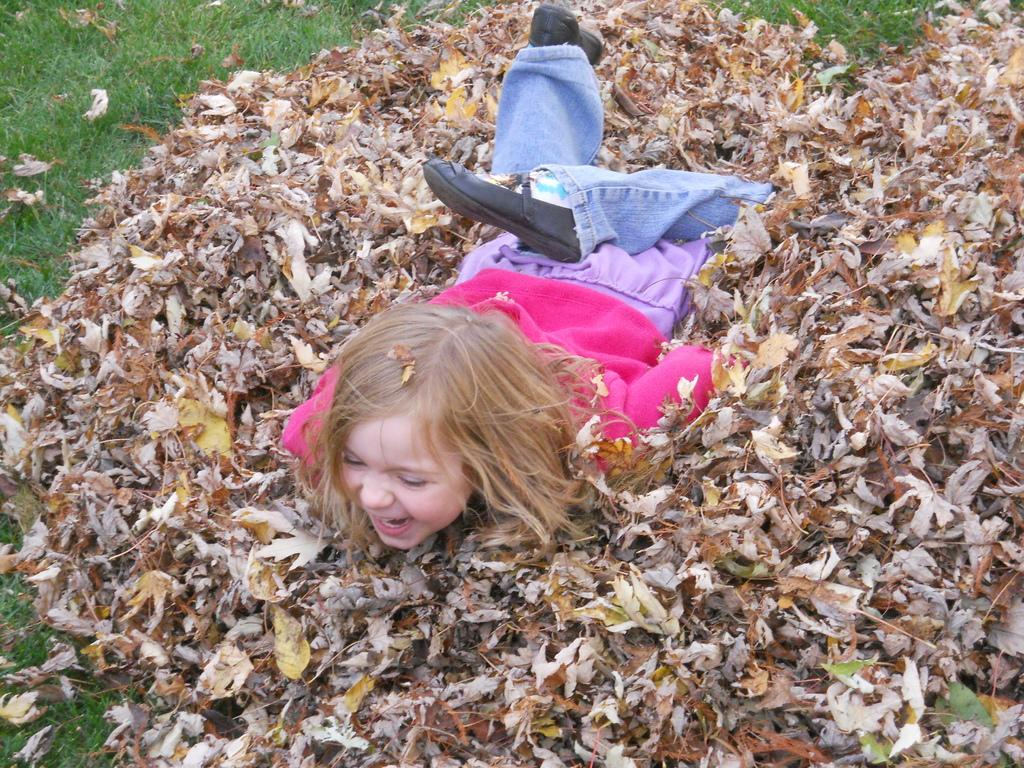What is the main subject of the image? The main subject of the image is a kid. What is the kid wearing? The kid is wearing a pink sweater, blue jeans, and black shoes. What is the kid doing in the image? The kid is sleeping on dry leaves. Where are the dry leaves located? The dry leaves are on the ground. What type of vegetation can be seen in the image? There is grass in the image. What type of street can be seen in the image? There is no street present in the image; it features a kid sleeping on dry leaves on the ground. What muscle is the kid exercising while sleeping on the dry leaves? The kid is not exercising any muscles while sleeping on the dry leaves; they are resting. 